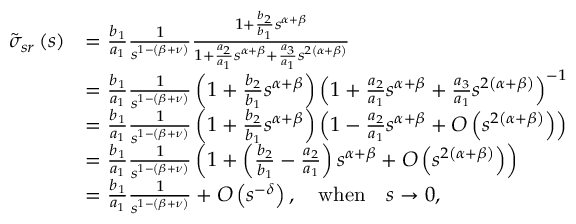<formula> <loc_0><loc_0><loc_500><loc_500>\begin{array} { r l } { \tilde { \sigma } _ { s r } \left ( s \right ) } & { = \frac { b _ { 1 } } { a _ { 1 } } \frac { 1 } { s ^ { 1 - \left ( \beta + \nu \right ) } } \frac { 1 + \frac { b _ { 2 } } { b _ { 1 } } s ^ { \alpha + \beta } } { 1 + \frac { a _ { 2 } } { a _ { 1 } } s ^ { \alpha + \beta } + \frac { a _ { 3 } } { a _ { 1 } } s ^ { 2 \left ( \alpha + \beta \right ) } } } \\ & { = \frac { b _ { 1 } } { a _ { 1 } } \frac { 1 } { s ^ { 1 - \left ( \beta + \nu \right ) } } \left ( 1 + \frac { b _ { 2 } } { b _ { 1 } } s ^ { \alpha + \beta } \right ) \left ( 1 + \frac { a _ { 2 } } { a _ { 1 } } s ^ { \alpha + \beta } + \frac { a _ { 3 } } { a _ { 1 } } s ^ { 2 \left ( \alpha + \beta \right ) } \right ) ^ { - 1 } } \\ & { = \frac { b _ { 1 } } { a _ { 1 } } \frac { 1 } { s ^ { 1 - \left ( \beta + \nu \right ) } } \left ( 1 + \frac { b _ { 2 } } { b _ { 1 } } s ^ { \alpha + \beta } \right ) \left ( 1 - \frac { a _ { 2 } } { a _ { 1 } } s ^ { \alpha + \beta } + O \left ( s ^ { 2 \left ( \alpha + \beta \right ) } \right ) \right ) } \\ & { = \frac { b _ { 1 } } { a _ { 1 } } \frac { 1 } { s ^ { 1 - \left ( \beta + \nu \right ) } } \left ( 1 + \left ( \frac { b _ { 2 } } { b _ { 1 } } - \frac { a _ { 2 } } { a _ { 1 } } \right ) s ^ { \alpha + \beta } + O \left ( s ^ { 2 \left ( \alpha + \beta \right ) } \right ) \right ) } \\ & { = \frac { b _ { 1 } } { a _ { 1 } } \frac { 1 } { s ^ { 1 - \left ( \beta + \nu \right ) } } + O \left ( s ^ { - \delta } \right ) , \quad w h e n \quad s \rightarrow 0 , } \end{array}</formula> 